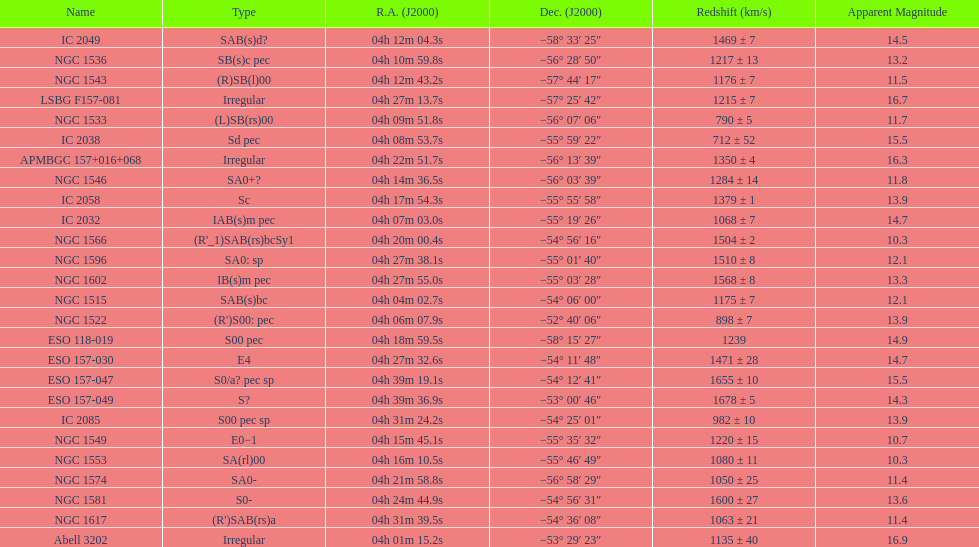What's the total of distinct "irregular" forms? 3. Would you mind parsing the complete table? {'header': ['Name', 'Type', 'R.A. (J2000)', 'Dec. (J2000)', 'Redshift (km/s)', 'Apparent Magnitude'], 'rows': [['IC 2049', 'SAB(s)d?', '04h\xa012m\xa004.3s', '−58°\xa033′\xa025″', '1469 ± 7', '14.5'], ['NGC 1536', 'SB(s)c pec', '04h\xa010m\xa059.8s', '−56°\xa028′\xa050″', '1217 ± 13', '13.2'], ['NGC 1543', '(R)SB(l)00', '04h\xa012m\xa043.2s', '−57°\xa044′\xa017″', '1176 ± 7', '11.5'], ['LSBG F157-081', 'Irregular', '04h\xa027m\xa013.7s', '−57°\xa025′\xa042″', '1215 ± 7', '16.7'], ['NGC 1533', '(L)SB(rs)00', '04h\xa009m\xa051.8s', '−56°\xa007′\xa006″', '790 ± 5', '11.7'], ['IC 2038', 'Sd pec', '04h\xa008m\xa053.7s', '−55°\xa059′\xa022″', '712 ± 52', '15.5'], ['APMBGC 157+016+068', 'Irregular', '04h\xa022m\xa051.7s', '−56°\xa013′\xa039″', '1350 ± 4', '16.3'], ['NGC 1546', 'SA0+?', '04h\xa014m\xa036.5s', '−56°\xa003′\xa039″', '1284 ± 14', '11.8'], ['IC 2058', 'Sc', '04h\xa017m\xa054.3s', '−55°\xa055′\xa058″', '1379 ± 1', '13.9'], ['IC 2032', 'IAB(s)m pec', '04h\xa007m\xa003.0s', '−55°\xa019′\xa026″', '1068 ± 7', '14.7'], ['NGC 1566', "(R'_1)SAB(rs)bcSy1", '04h\xa020m\xa000.4s', '−54°\xa056′\xa016″', '1504 ± 2', '10.3'], ['NGC 1596', 'SA0: sp', '04h\xa027m\xa038.1s', '−55°\xa001′\xa040″', '1510 ± 8', '12.1'], ['NGC 1602', 'IB(s)m pec', '04h\xa027m\xa055.0s', '−55°\xa003′\xa028″', '1568 ± 8', '13.3'], ['NGC 1515', 'SAB(s)bc', '04h\xa004m\xa002.7s', '−54°\xa006′\xa000″', '1175 ± 7', '12.1'], ['NGC 1522', "(R')S00: pec", '04h\xa006m\xa007.9s', '−52°\xa040′\xa006″', '898 ± 7', '13.9'], ['ESO 118-019', 'S00 pec', '04h\xa018m\xa059.5s', '−58°\xa015′\xa027″', '1239', '14.9'], ['ESO 157-030', 'E4', '04h\xa027m\xa032.6s', '−54°\xa011′\xa048″', '1471 ± 28', '14.7'], ['ESO 157-047', 'S0/a? pec sp', '04h\xa039m\xa019.1s', '−54°\xa012′\xa041″', '1655 ± 10', '15.5'], ['ESO 157-049', 'S?', '04h\xa039m\xa036.9s', '−53°\xa000′\xa046″', '1678 ± 5', '14.3'], ['IC 2085', 'S00 pec sp', '04h\xa031m\xa024.2s', '−54°\xa025′\xa001″', '982 ± 10', '13.9'], ['NGC 1549', 'E0−1', '04h\xa015m\xa045.1s', '−55°\xa035′\xa032″', '1220 ± 15', '10.7'], ['NGC 1553', 'SA(rl)00', '04h\xa016m\xa010.5s', '−55°\xa046′\xa049″', '1080 ± 11', '10.3'], ['NGC 1574', 'SA0-', '04h\xa021m\xa058.8s', '−56°\xa058′\xa029″', '1050 ± 25', '11.4'], ['NGC 1581', 'S0-', '04h\xa024m\xa044.9s', '−54°\xa056′\xa031″', '1600 ± 27', '13.6'], ['NGC 1617', "(R')SAB(rs)a", '04h\xa031m\xa039.5s', '−54°\xa036′\xa008″', '1063 ± 21', '11.4'], ['Abell 3202', 'Irregular', '04h\xa001m\xa015.2s', '−53°\xa029′\xa023″', '1135 ± 40', '16.9']]} 